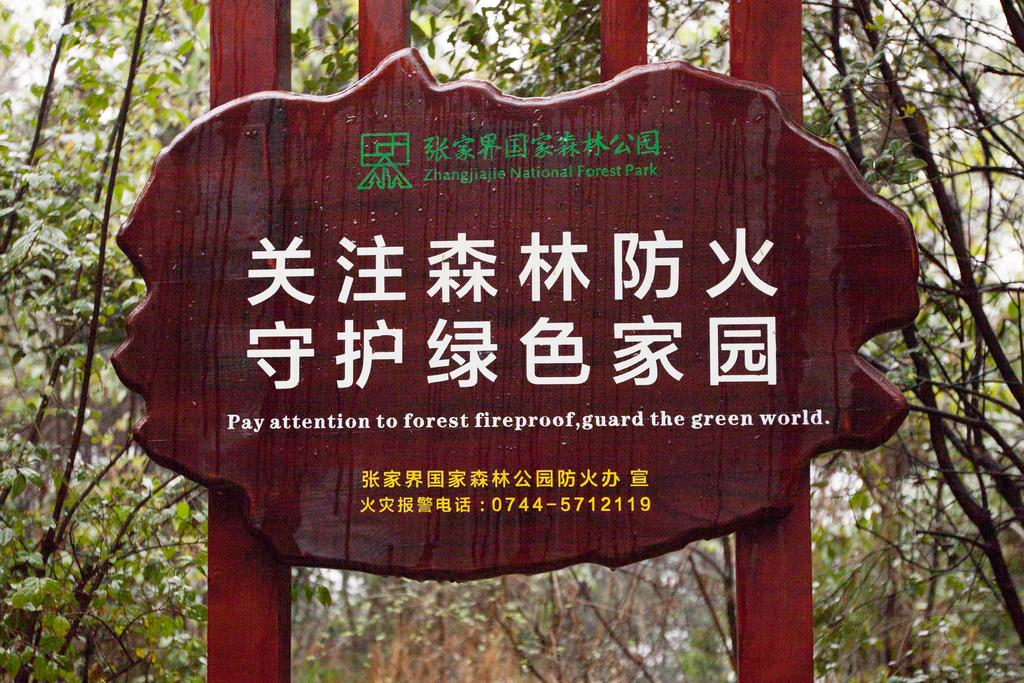What is attached to the poles in the image? There is a board attached to the poles in the image. What can be seen on the board? There is something written on the board. What type of vegetation is visible in the background of the image? There are trees with leaves and branches in the background of the image. What type of throat-soothing syrup is advertised on the board in the image? There is no throat-soothing syrup or any advertisement mentioned in the image. Can you tell me how many pancakes are stacked on the board in the image? There are no pancakes present in the image; it features a board with something written on it. 